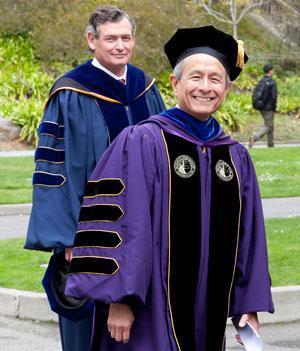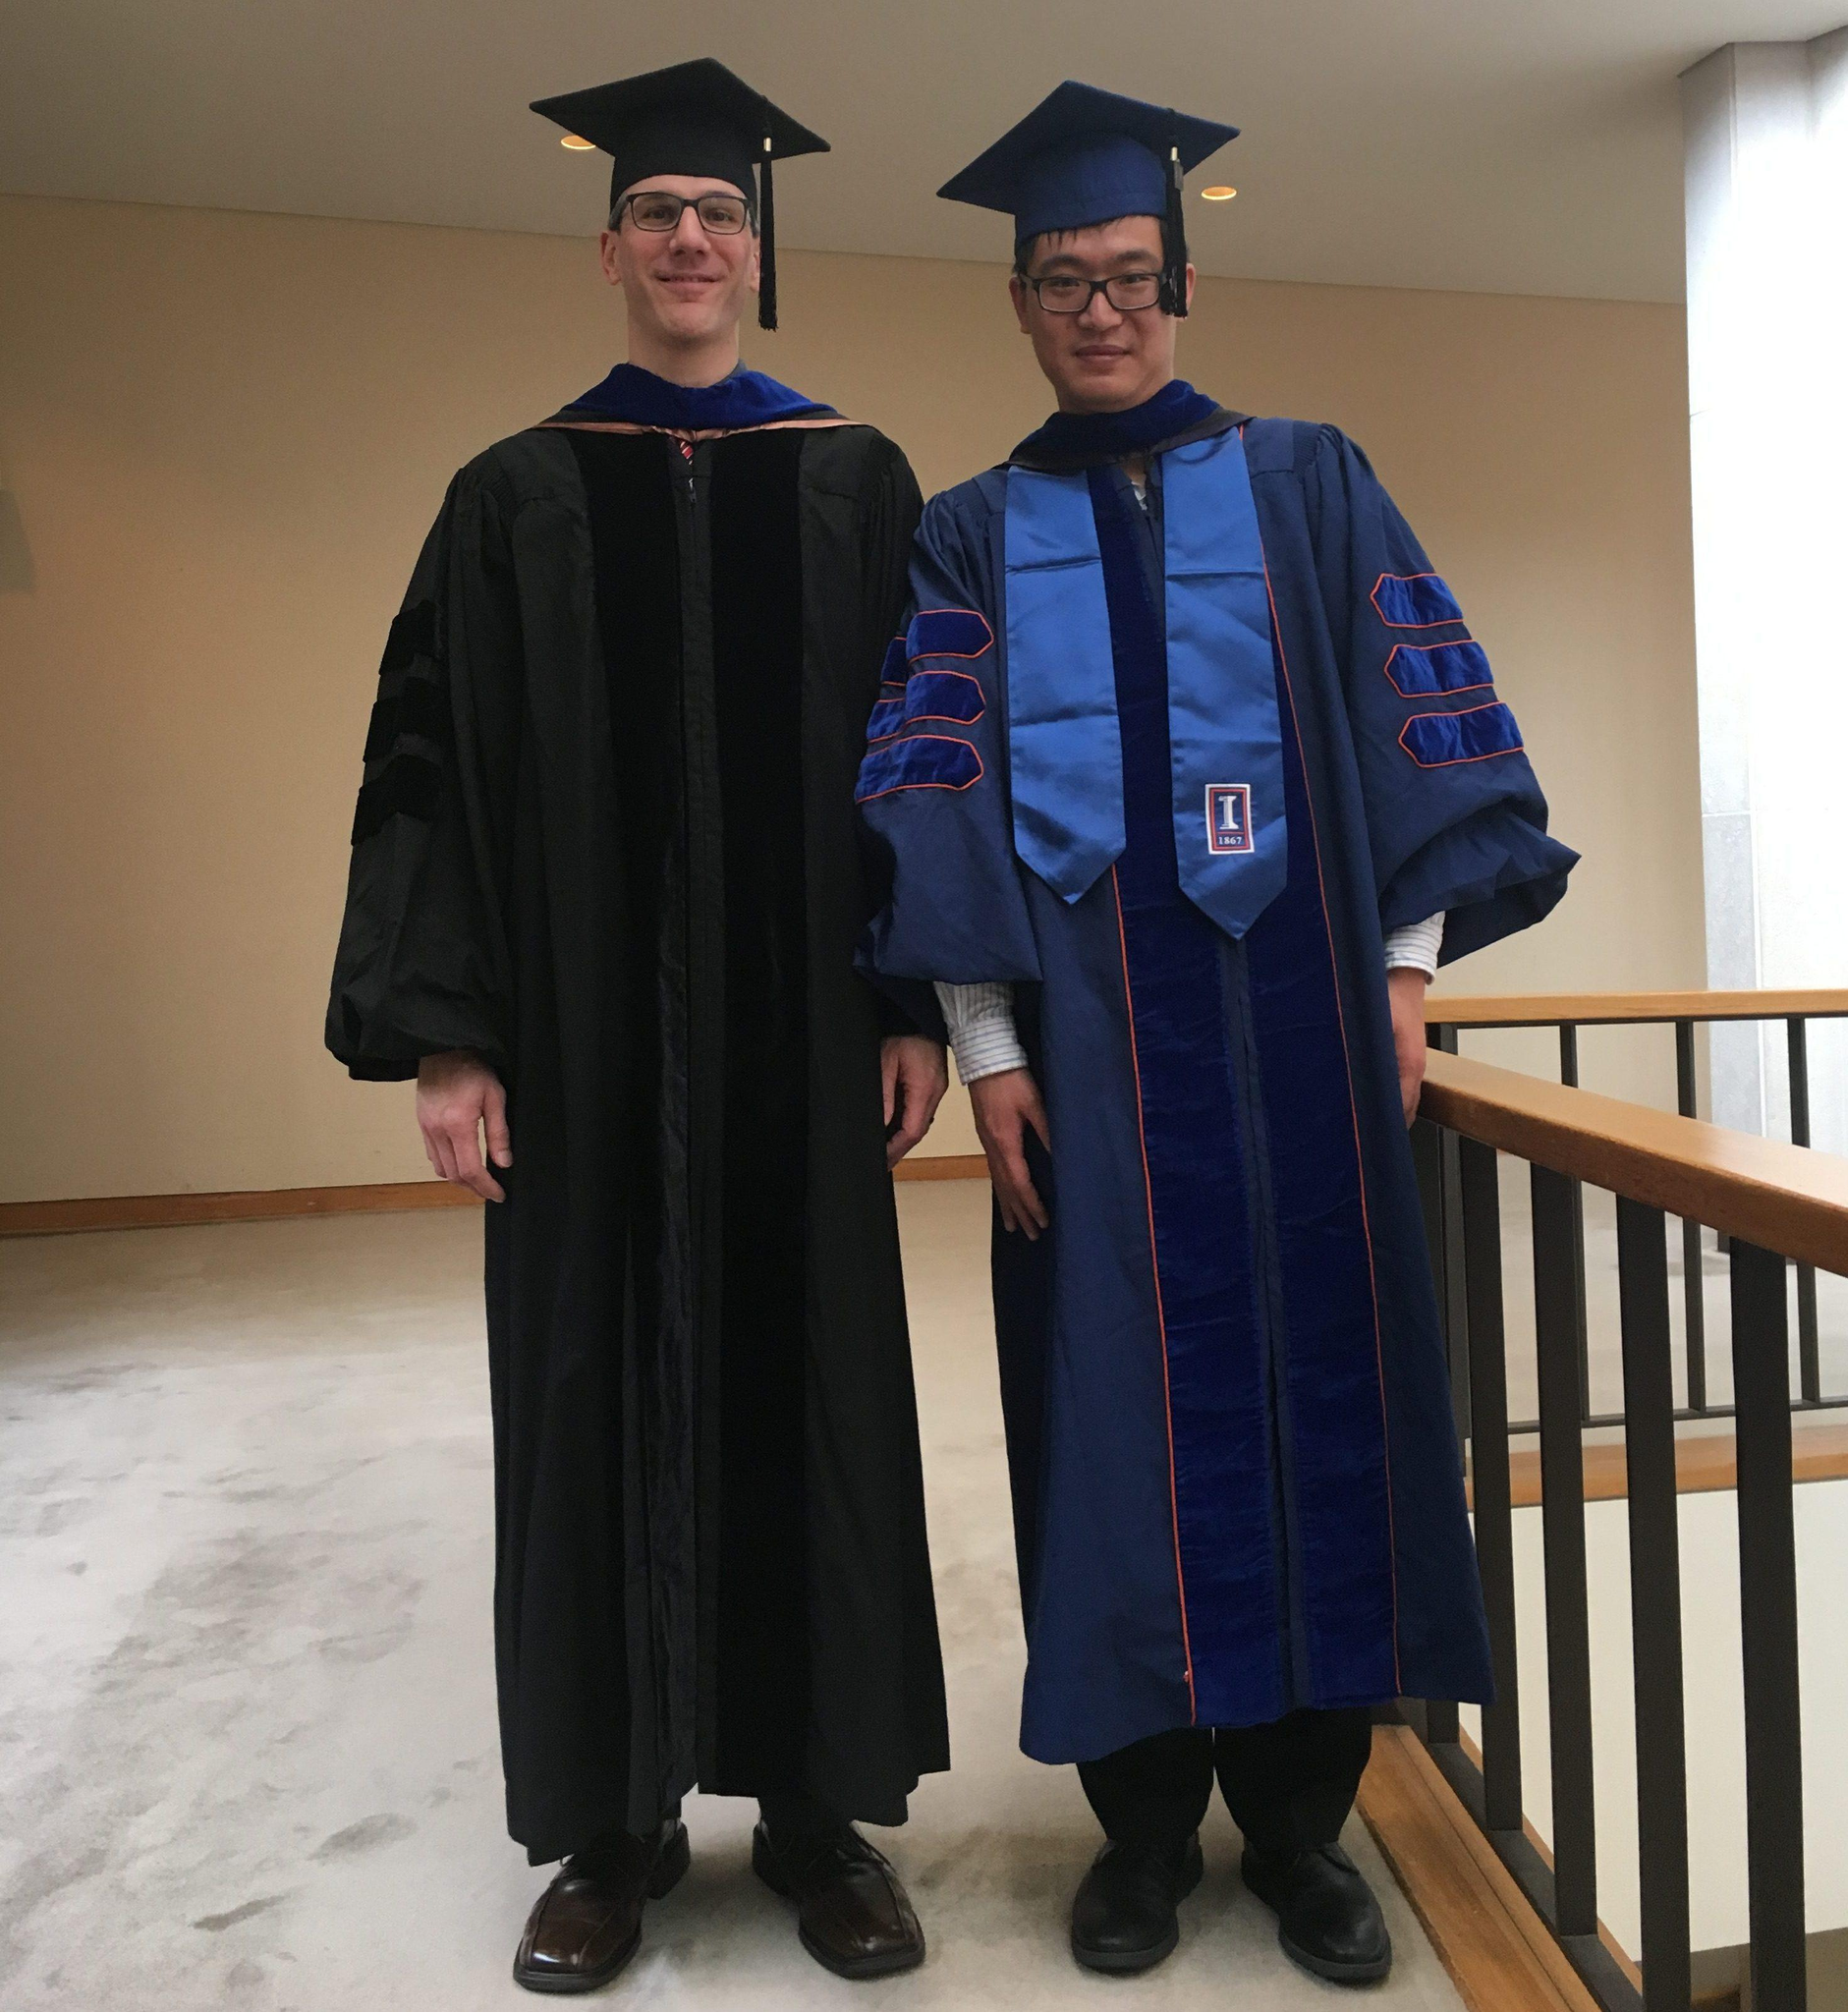The first image is the image on the left, the second image is the image on the right. Considering the images on both sides, is "No more than two people in graduation robes can be seen in either picture." valid? Answer yes or no. Yes. The first image is the image on the left, the second image is the image on the right. Considering the images on both sides, is "One image features a single graduate in the foreground raising at least one hand in the air, and wearing a royal purple robe with yellow around the neck and a hat with a tassle." valid? Answer yes or no. No. 